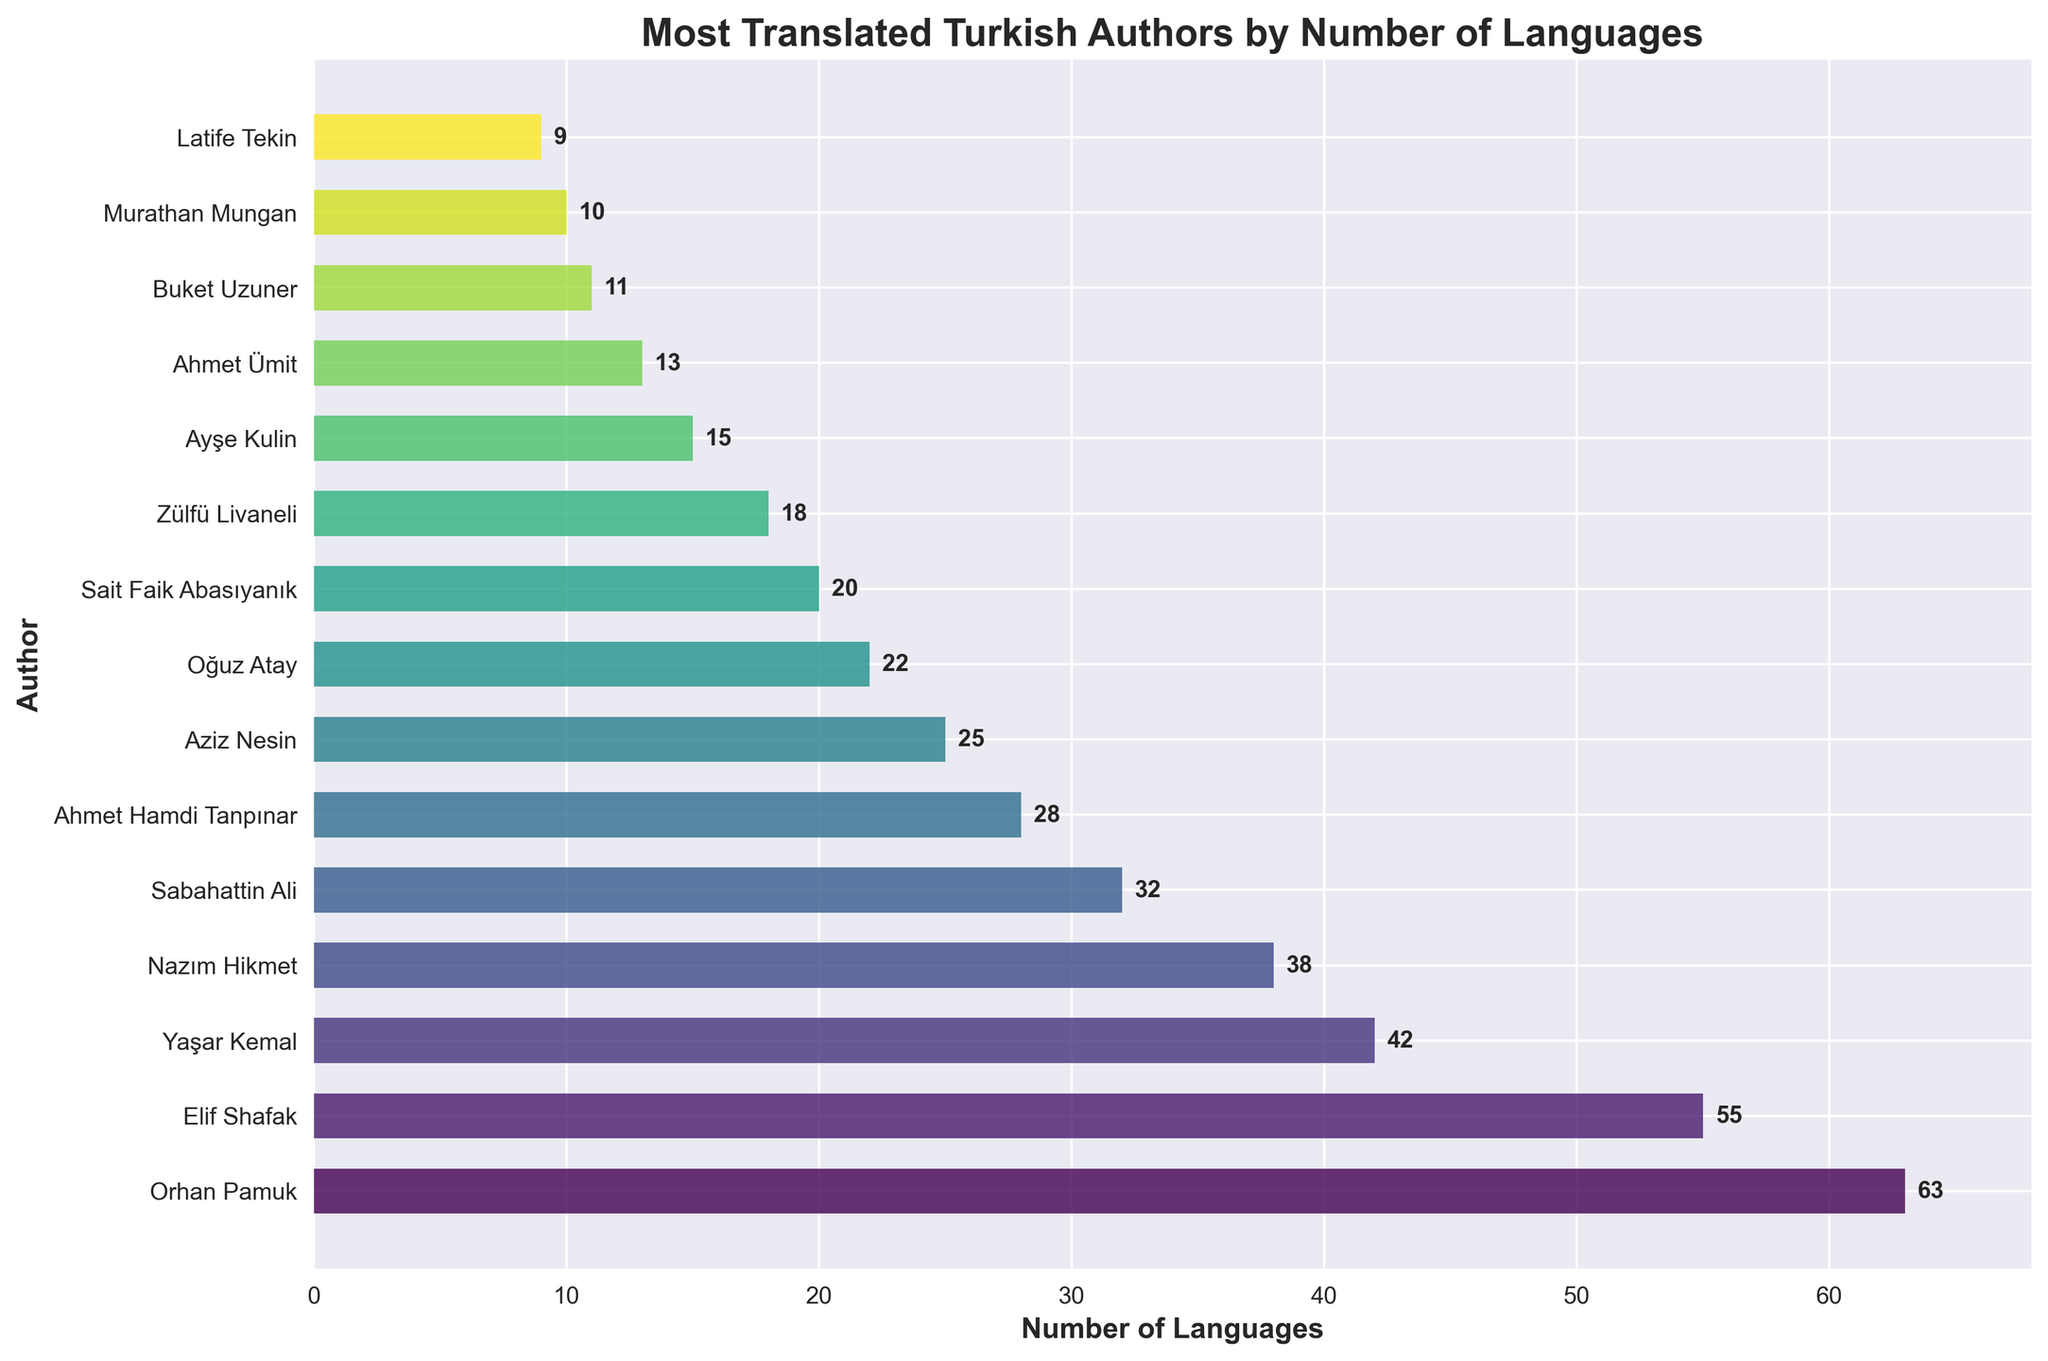Which author is translated into the most languages? The bar chart indicates the number of languages each author has been translated into. By looking at the lengths of the bars, we can see that Orhan Pamuk has the longest bar, indicating he has the highest number of translations.
Answer: Orhan Pamuk How many more languages has Orhan Pamuk been translated into compared to Elif Shafak? Orhan Pamuk has been translated into 63 languages, and Elif Shafak has been translated into 55 languages. The difference is 63 - 55 = 8.
Answer: 8 Which author is translated into exactly 25 languages? By looking at the author names aligned with the bars indicating 25 languages, we find that Aziz Nesin is the author translated into exactly 25 languages.
Answer: Aziz Nesin What is the total number of languages into which the top 3 authors have been translated? The top 3 authors are Orhan Pamuk (63), Elif Shafak (55), and Yaşar Kemal (42). The total number of languages is 63 + 55 + 42 = 160.
Answer: 160 Which authors have been translated into less than 20 languages? The authors with bars less than 20 languages are Zülfü Livaneli (18), Ayşe Kulin (15), Ahmet Ümit (13), Buket Uzuner (11), Murathan Mungan (10), and Latife Tekin (9).
Answer: Zülfü Livaneli, Ayşe Kulin, Ahmet Ümit, Buket Uzuner, Murathan Mungan, Latife Tekin Which two authors are translated into a similar number of languages and what is that number? The bars closest in length are those of Sabahattin Ali and Ahmet Hamdi Tanpınar. Sabahattin Ali is translated into 32 languages, and Ahmet Hamdi Tanpınar is translated into 28 languages.
Answer: Sabahattin Ali (32), Ahmet Hamdi Tanpınar (28) How many authors have been translated into more than 30 languages? The authors with bars extending beyond 30 languages are Orhan Pamuk, Elif Shafak, Yaşar Kemal, Nazım Hikmet, and Sabahattin Ali. This totals 5 authors.
Answer: 5 What is the average number of languages that authors have been translated into? Sum all the languages the authors have been translated into: 63 + 55 + 42 + 38 + 32 + 28 + 25 + 22 + 20 + 18 + 15 + 13 + 11 + 10 + 9 = 401. Divide by the number of authors (15): 401 / 15 ≈ 26.73.
Answer: 26.73 Is the number of languages that Yaşar Kemal has been translated into greater than the sum of languages for the bottom 3 authors? Yaşar Kemal has been translated into 42 languages. The bottom 3 authors are Buket Uzuner (11), Murathan Mungan (10), and Latife Tekin (9). Their sum is 11 + 10 + 9 = 30. 42 is greater than 30.
Answer: Yes 